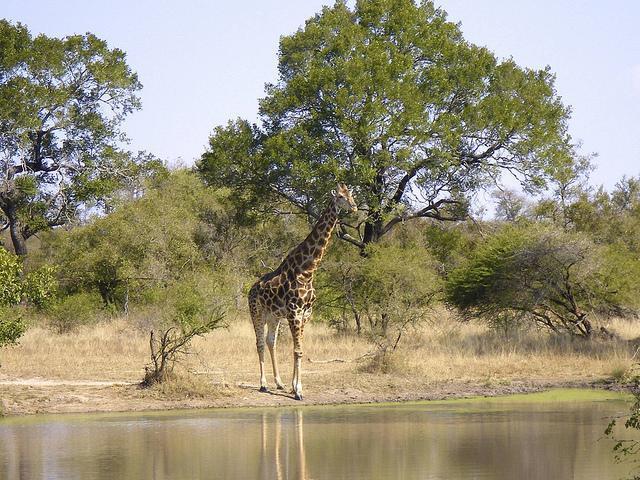How many giraffes are visible?
Give a very brief answer. 1. 